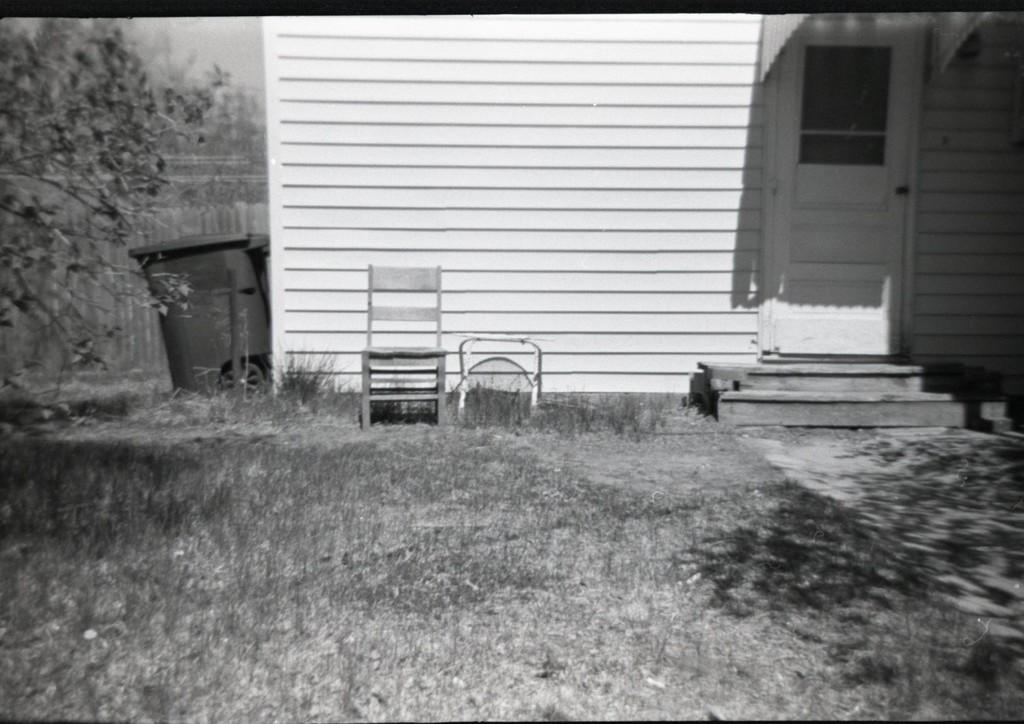In one or two sentences, can you explain what this image depicts? In this image I can see a building and in the front of it I can see an open grass ground, a door, stairs and a chair. On the left side of the image I can see a tree, a container and I can see this image is black and white in colour. 